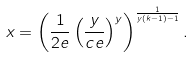<formula> <loc_0><loc_0><loc_500><loc_500>x = \left ( \frac { 1 } { 2 e } \left ( \frac { y } { c e } \right ) ^ { y } \right ) ^ { \frac { 1 } { y ( k - 1 ) - 1 } } .</formula> 